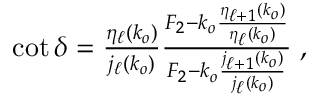Convert formula to latex. <formula><loc_0><loc_0><loc_500><loc_500>\begin{array} { r } { \cot \delta = \frac { \eta _ { \ell } ( k _ { o } ) } { j _ { \ell } ( k _ { o } ) } \frac { F _ { 2 } - k _ { o } \frac { \eta _ { \ell + 1 } ( k _ { o } ) } { \eta _ { \ell } ( k _ { o } ) } } { F _ { 2 } - k _ { o } \frac { j _ { \ell + 1 } ( k _ { o } ) } { j _ { \ell } ( k _ { o } ) } } \, , } \end{array}</formula> 